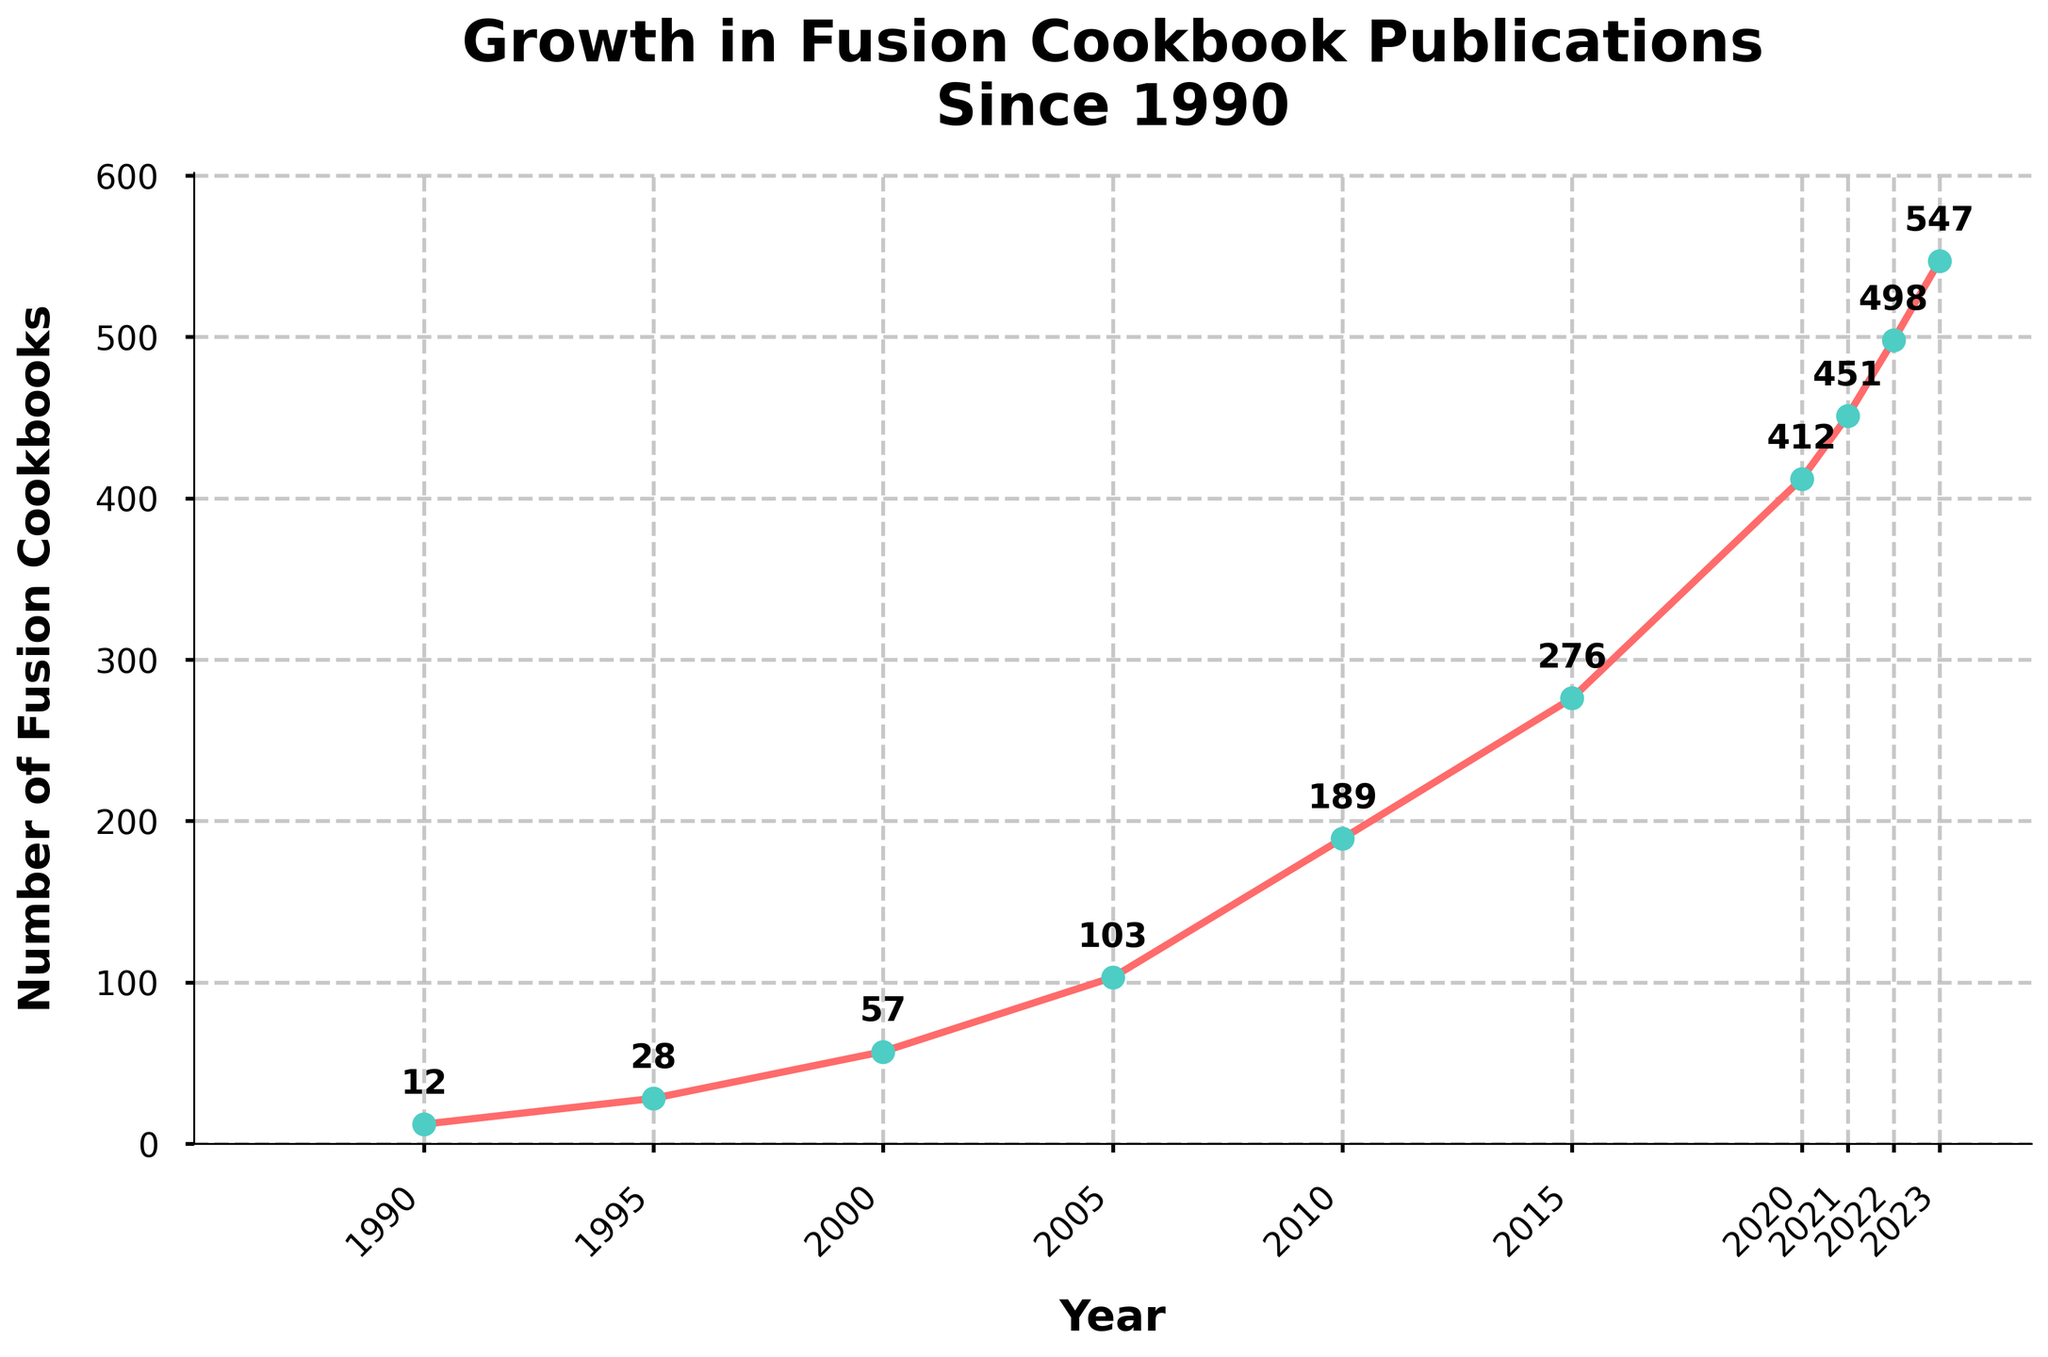When did the number of fusion cookbooks first surpass 100? First, locate the year where the number of cookbooks surpasses 100. In the figure, this happens in 2005 as it shows 103 cookbooks.
Answer: 2005 Between which years did the number of fusion cookbooks published experience the highest growth rate? Calculate the growth rates by examining the increments between consecutive data points. The highest growth is between 2015 (276) and 2020 (412), showing an increase of 136 cookbooks.
Answer: 2015 to 2020 What was the average number of fusion cookbooks published in the 1990s? In the 1990s, the data points are for 1990 (12) and 1995 (28). Average = (12 + 28) / 2 = 20.
Answer: 20 Compare the number of fusion cookbooks published in 2022 to that in 2023. The number of cookbooks in 2022 was 498, and in 2023 it was 547. 547 > 498, indicating an increase.
Answer: 2023 had more By how many fusion cookbooks did the count increase from 1990 to 2023? Subtract the values of 1990 and 2023: 547 (2023) - 12 (1990) = 535.
Answer: 535 During which decade did the number of fusion cookbooks published more than double? Compare each decade's starting and ending numbers. Between 1990 (12) and 2000 (57), the number more than quadrupled. Similarly, from 2000 (57) to 2010 (189), it more than tripled. From 2010 (189) to 2020 (412), it more than doubled.
Answer: 2000 to 2010; 2010 to 2020 What color and style are the markers used on the plot? In the visual, the markers are displayed in a greenish-blue (similar to teal) with circular shapes.
Answer: Greenish-blue circles Is the growth trend in the number of fusion cookbooks linear or exponential? The visual shows rapid increases, especially in the latter years, indicating an exponential growth trend.
Answer: Exponential 